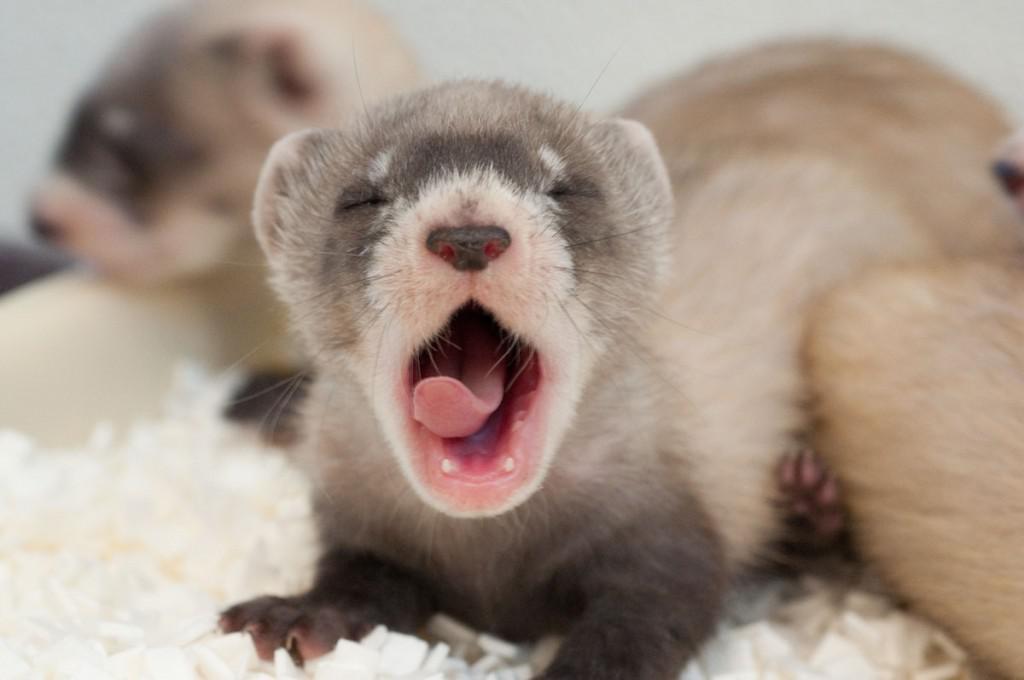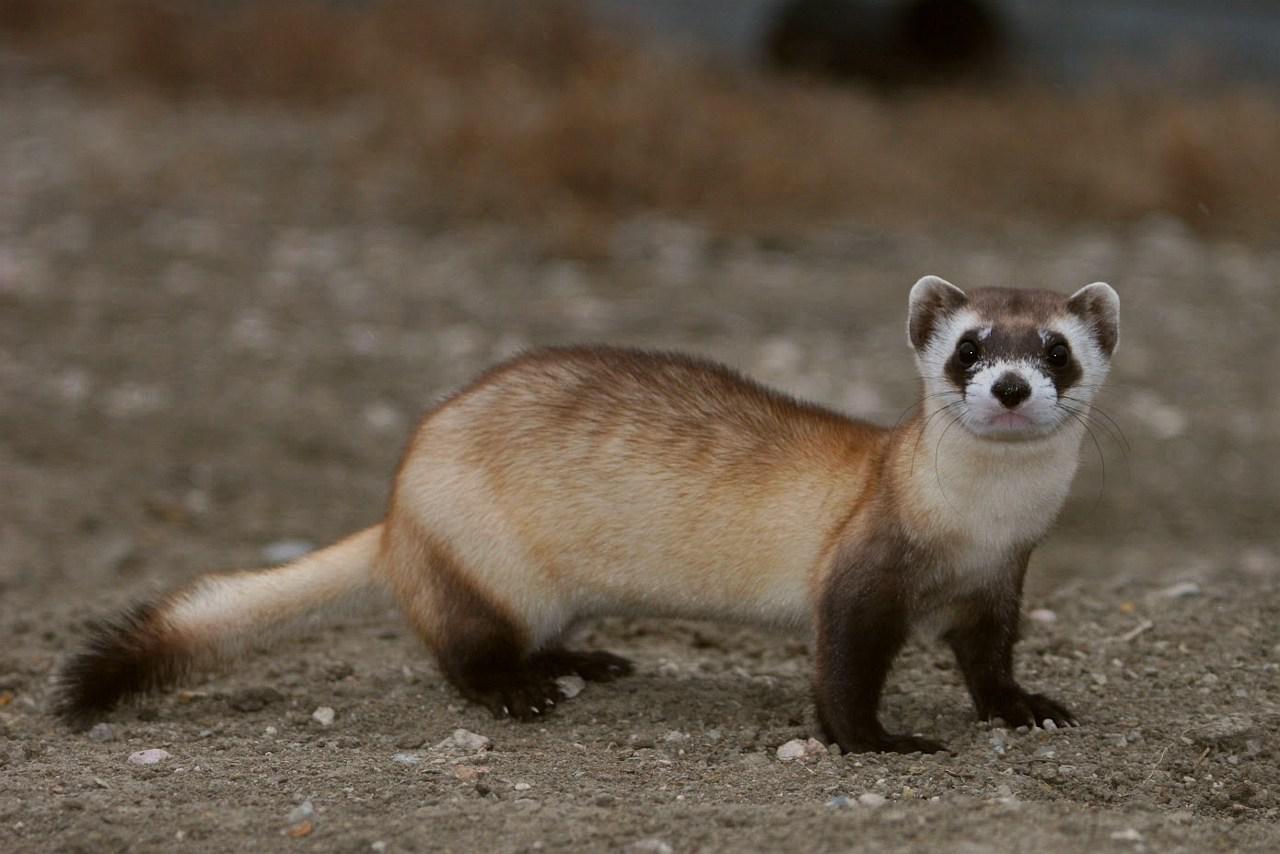The first image is the image on the left, the second image is the image on the right. Analyze the images presented: Is the assertion "There are multiple fuzzy animals facing the same direction in each image." valid? Answer yes or no. No. The first image is the image on the left, the second image is the image on the right. For the images shown, is this caption "At least one image has a single animal standing alone." true? Answer yes or no. Yes. 